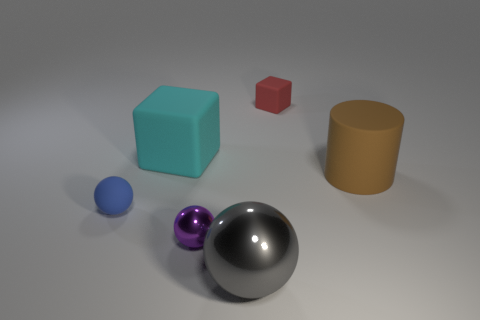Is there a tiny blue sphere that has the same material as the red thing?
Offer a terse response. Yes. There is a purple ball that is the same size as the blue matte object; what material is it?
Make the answer very short. Metal. How many other objects are the same shape as the cyan thing?
Keep it short and to the point. 1. There is a red object that is made of the same material as the large cyan block; what size is it?
Make the answer very short. Small. There is a small object that is both behind the tiny purple metal thing and left of the tiny red matte block; what material is it?
Provide a succinct answer. Rubber. How many blue spheres are the same size as the purple metallic thing?
Your answer should be very brief. 1. There is a tiny blue object that is the same shape as the big shiny object; what material is it?
Offer a terse response. Rubber. What number of things are small rubber things behind the big cylinder or small things in front of the red thing?
Keep it short and to the point. 3. There is a small blue object; is its shape the same as the big thing in front of the brown rubber cylinder?
Make the answer very short. Yes. What shape is the object behind the cube that is in front of the tiny object behind the small rubber ball?
Offer a very short reply. Cube. 